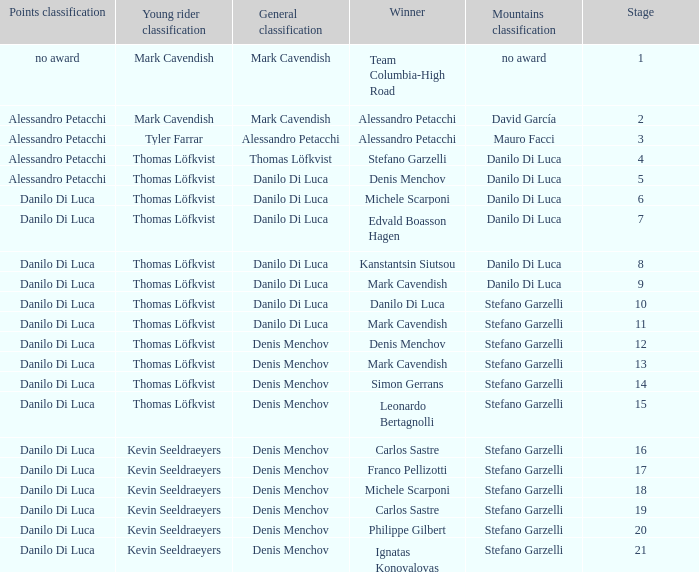Would you be able to parse every entry in this table? {'header': ['Points classification', 'Young rider classification', 'General classification', 'Winner', 'Mountains classification', 'Stage'], 'rows': [['no award', 'Mark Cavendish', 'Mark Cavendish', 'Team Columbia-High Road', 'no award', '1'], ['Alessandro Petacchi', 'Mark Cavendish', 'Mark Cavendish', 'Alessandro Petacchi', 'David García', '2'], ['Alessandro Petacchi', 'Tyler Farrar', 'Alessandro Petacchi', 'Alessandro Petacchi', 'Mauro Facci', '3'], ['Alessandro Petacchi', 'Thomas Löfkvist', 'Thomas Löfkvist', 'Stefano Garzelli', 'Danilo Di Luca', '4'], ['Alessandro Petacchi', 'Thomas Löfkvist', 'Danilo Di Luca', 'Denis Menchov', 'Danilo Di Luca', '5'], ['Danilo Di Luca', 'Thomas Löfkvist', 'Danilo Di Luca', 'Michele Scarponi', 'Danilo Di Luca', '6'], ['Danilo Di Luca', 'Thomas Löfkvist', 'Danilo Di Luca', 'Edvald Boasson Hagen', 'Danilo Di Luca', '7'], ['Danilo Di Luca', 'Thomas Löfkvist', 'Danilo Di Luca', 'Kanstantsin Siutsou', 'Danilo Di Luca', '8'], ['Danilo Di Luca', 'Thomas Löfkvist', 'Danilo Di Luca', 'Mark Cavendish', 'Danilo Di Luca', '9'], ['Danilo Di Luca', 'Thomas Löfkvist', 'Danilo Di Luca', 'Danilo Di Luca', 'Stefano Garzelli', '10'], ['Danilo Di Luca', 'Thomas Löfkvist', 'Danilo Di Luca', 'Mark Cavendish', 'Stefano Garzelli', '11'], ['Danilo Di Luca', 'Thomas Löfkvist', 'Denis Menchov', 'Denis Menchov', 'Stefano Garzelli', '12'], ['Danilo Di Luca', 'Thomas Löfkvist', 'Denis Menchov', 'Mark Cavendish', 'Stefano Garzelli', '13'], ['Danilo Di Luca', 'Thomas Löfkvist', 'Denis Menchov', 'Simon Gerrans', 'Stefano Garzelli', '14'], ['Danilo Di Luca', 'Thomas Löfkvist', 'Denis Menchov', 'Leonardo Bertagnolli', 'Stefano Garzelli', '15'], ['Danilo Di Luca', 'Kevin Seeldraeyers', 'Denis Menchov', 'Carlos Sastre', 'Stefano Garzelli', '16'], ['Danilo Di Luca', 'Kevin Seeldraeyers', 'Denis Menchov', 'Franco Pellizotti', 'Stefano Garzelli', '17'], ['Danilo Di Luca', 'Kevin Seeldraeyers', 'Denis Menchov', 'Michele Scarponi', 'Stefano Garzelli', '18'], ['Danilo Di Luca', 'Kevin Seeldraeyers', 'Denis Menchov', 'Carlos Sastre', 'Stefano Garzelli', '19'], ['Danilo Di Luca', 'Kevin Seeldraeyers', 'Denis Menchov', 'Philippe Gilbert', 'Stefano Garzelli', '20'], ['Danilo Di Luca', 'Kevin Seeldraeyers', 'Denis Menchov', 'Ignatas Konovalovas', 'Stefano Garzelli', '21']]} When  thomas löfkvist is the general classification who is the winner? Stefano Garzelli. 